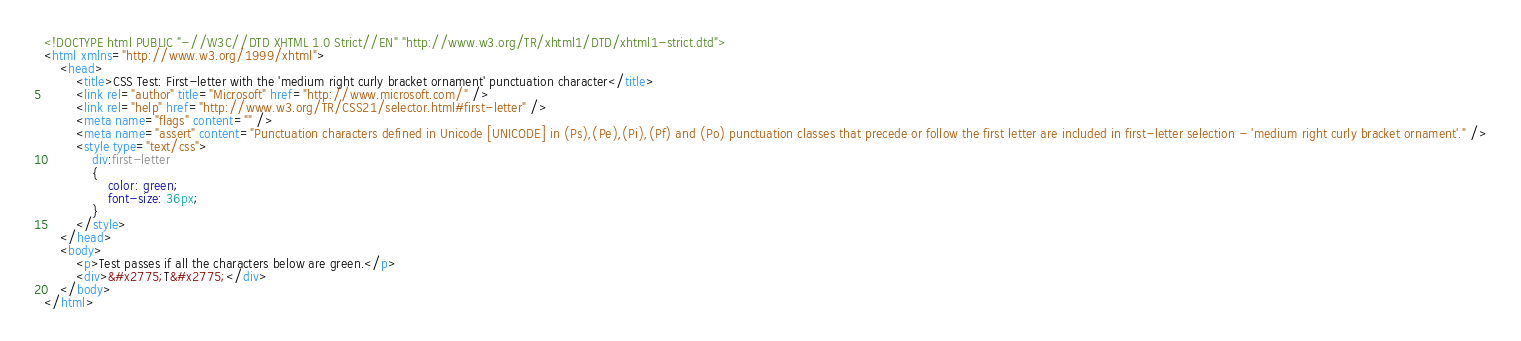<code> <loc_0><loc_0><loc_500><loc_500><_HTML_><!DOCTYPE html PUBLIC "-//W3C//DTD XHTML 1.0 Strict//EN" "http://www.w3.org/TR/xhtml1/DTD/xhtml1-strict.dtd">
<html xmlns="http://www.w3.org/1999/xhtml">
    <head>
        <title>CSS Test: First-letter with the 'medium right curly bracket ornament' punctuation character</title>
        <link rel="author" title="Microsoft" href="http://www.microsoft.com/" />
        <link rel="help" href="http://www.w3.org/TR/CSS21/selector.html#first-letter" />
        <meta name="flags" content="" />
        <meta name="assert" content="Punctuation characters defined in Unicode [UNICODE] in (Ps),(Pe),(Pi),(Pf) and (Po) punctuation classes that precede or follow the first letter are included in first-letter selection - 'medium right curly bracket ornament'." />
        <style type="text/css">
            div:first-letter
            {
                color: green;
                font-size: 36px;
            }
        </style>
    </head>
    <body>
        <p>Test passes if all the characters below are green.</p>
        <div>&#x2775;T&#x2775;</div>
    </body>
</html></code> 